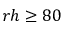Convert formula to latex. <formula><loc_0><loc_0><loc_500><loc_500>r h \geq 8 0</formula> 